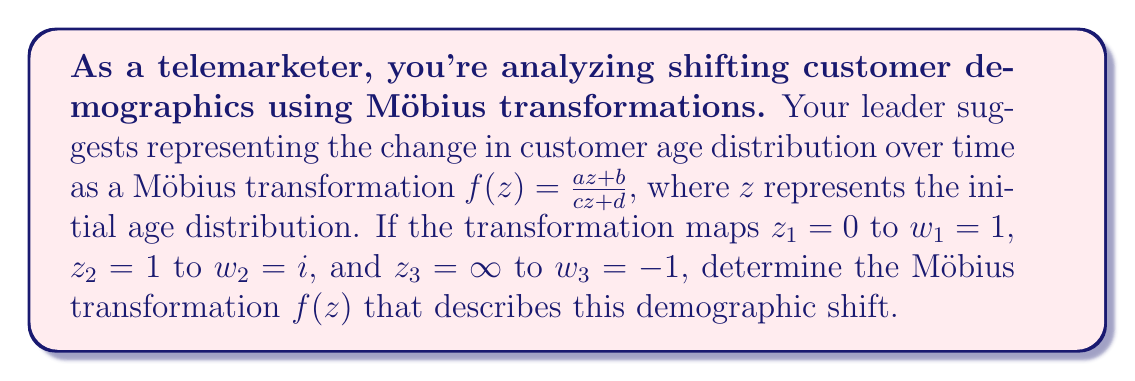Solve this math problem. To solve this problem, we'll follow these steps:

1) The general form of a Möbius transformation is $f(z) = \frac{az + b}{cz + d}$. We need to find the values of $a$, $b$, $c$, and $d$.

2) Given the three mappings, we can set up three equations:

   $f(0) = 1$
   $f(1) = i$
   $f(\infty) = -1$

3) From $f(0) = 1$, we get:
   $\frac{b}{d} = 1$ or $b = d$

4) From $f(\infty) = -1$, we get:
   $\lim_{z \to \infty} \frac{az + b}{cz + d} = \frac{a}{c} = -1$ or $a = -c$

5) Now, let's use $f(1) = i$:
   $\frac{a + b}{c + d} = i$

6) Substituting $a = -c$ and $b = d$:
   $\frac{-c + d}{c + d} = i$

7) Multiply both sides by $(c + d)$:
   $-c + d = i(c + d)$
   $-c + d = ic + id$

8) Equating real and imaginary parts:
   Real: $-c = 0$
   Imaginary: $d = c$

9) From steps 3 and 8, we can conclude that $b = d = c$ and $a = -c$.

10) The Möbius transformation is determined up to a constant factor. We can choose $c = 1$ for simplicity.

11) Therefore, $a = -1$, $b = 1$, $c = 1$, and $d = 1$.

12) The final Möbius transformation is:
    $f(z) = \frac{-z + 1}{z + 1}$

This transformation represents how the customer age distribution shifts over time, providing valuable insight for tailoring marketing strategies.
Answer: $f(z) = \frac{-z + 1}{z + 1}$ 